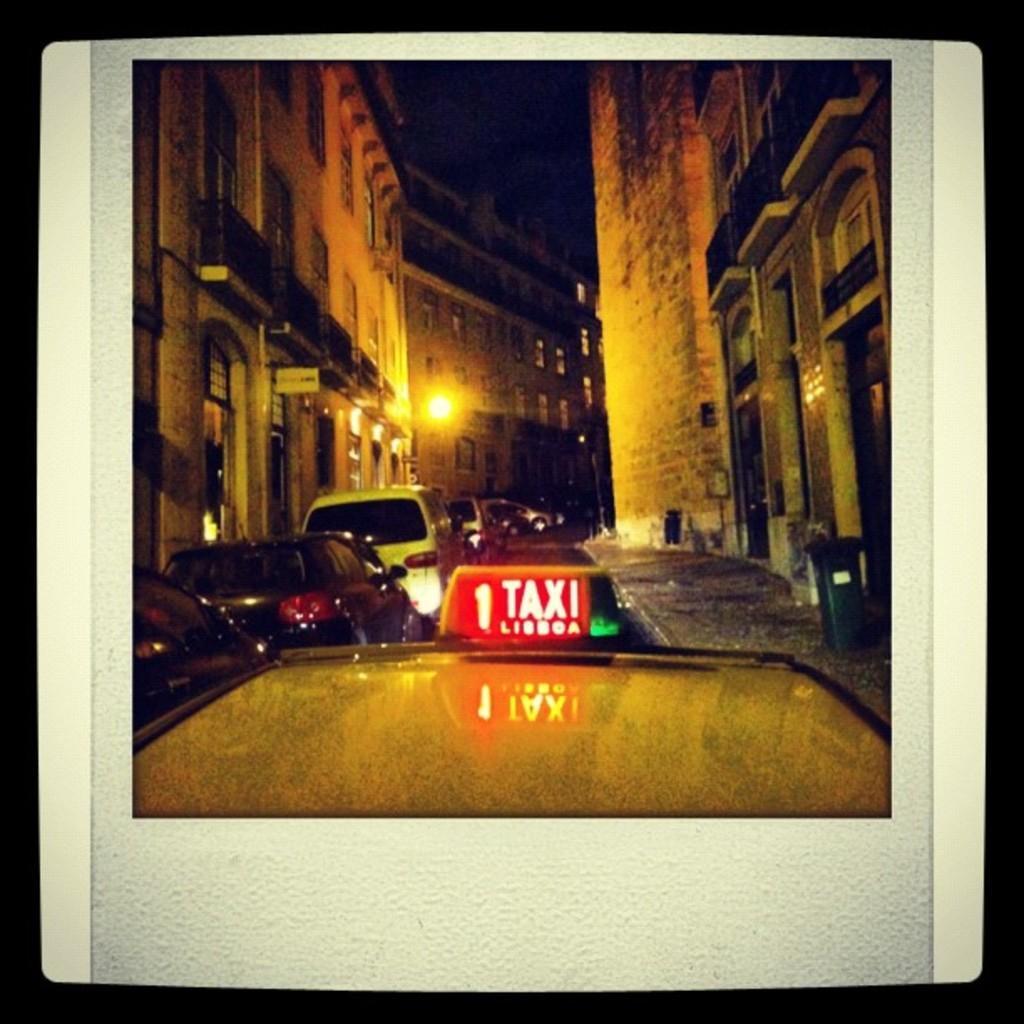Please provide a concise description of this image. In this image I can see the vehicles. On the left and right side, I can see the buildings. I can see the light. 